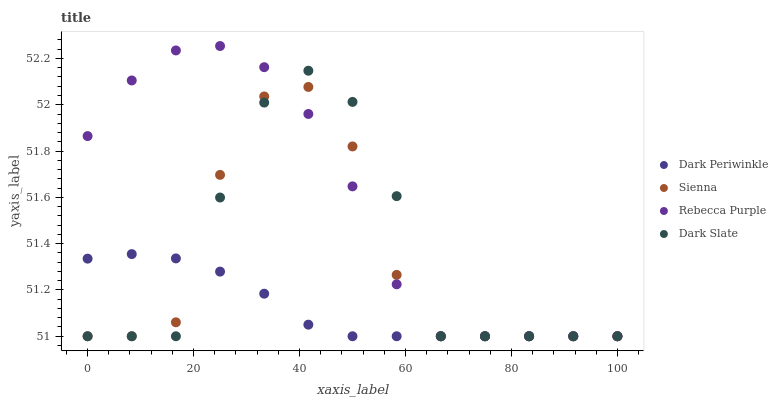Does Dark Periwinkle have the minimum area under the curve?
Answer yes or no. Yes. Does Rebecca Purple have the maximum area under the curve?
Answer yes or no. Yes. Does Dark Slate have the minimum area under the curve?
Answer yes or no. No. Does Dark Slate have the maximum area under the curve?
Answer yes or no. No. Is Dark Periwinkle the smoothest?
Answer yes or no. Yes. Is Dark Slate the roughest?
Answer yes or no. Yes. Is Dark Slate the smoothest?
Answer yes or no. No. Is Dark Periwinkle the roughest?
Answer yes or no. No. Does Sienna have the lowest value?
Answer yes or no. Yes. Does Rebecca Purple have the highest value?
Answer yes or no. Yes. Does Dark Slate have the highest value?
Answer yes or no. No. Does Rebecca Purple intersect Sienna?
Answer yes or no. Yes. Is Rebecca Purple less than Sienna?
Answer yes or no. No. Is Rebecca Purple greater than Sienna?
Answer yes or no. No. 